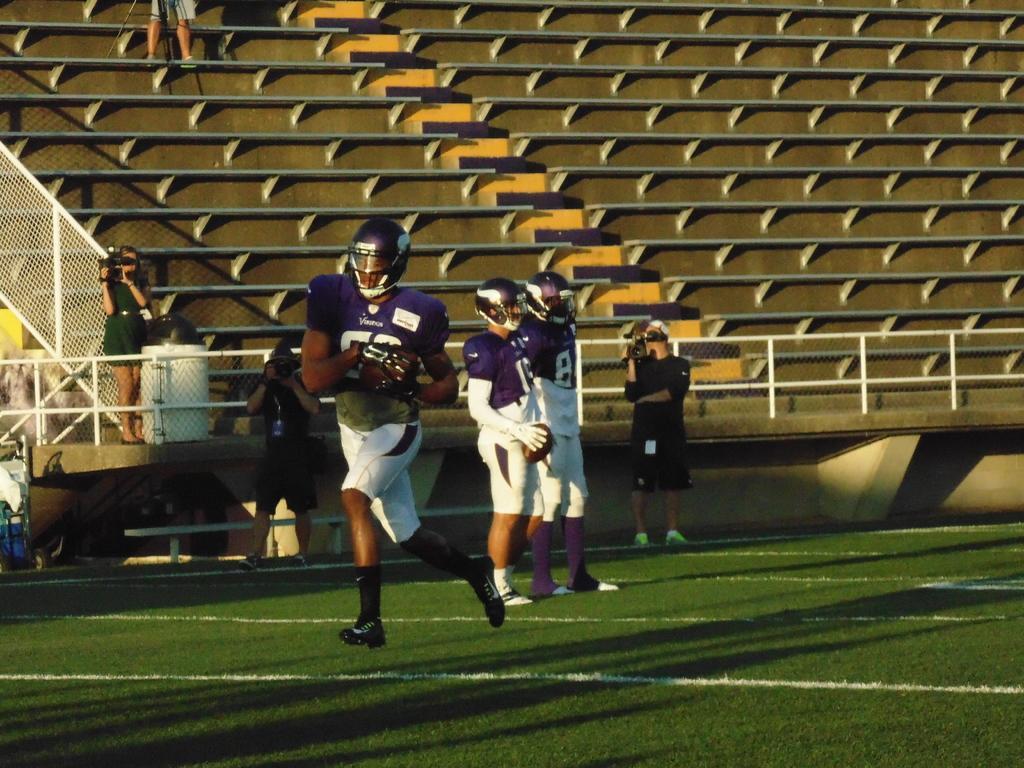Please provide a concise description of this image. In this image, we can see people wearing sports dress, gloves and are wearing helmets and there are some other people holding cameras. In the background, we can see benches, fences and some other objects. At the bottom, there is ground. 